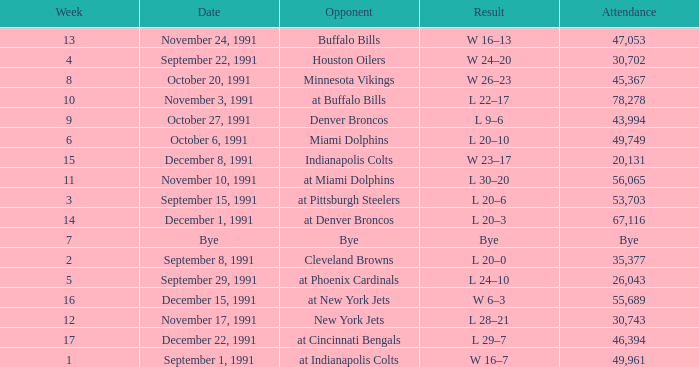What was the result of the game after Week 13 on December 8, 1991? W 23–17. 